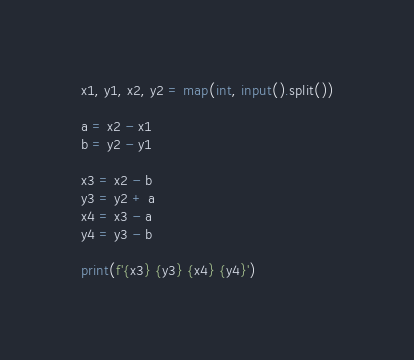<code> <loc_0><loc_0><loc_500><loc_500><_Python_>x1, y1, x2, y2 = map(int, input().split())

a = x2 - x1
b = y2 - y1

x3 = x2 - b
y3 = y2 + a
x4 = x3 - a
y4 = y3 - b

print(f'{x3} {y3} {x4} {y4}')</code> 